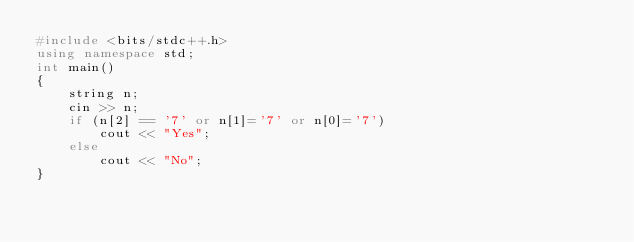Convert code to text. <code><loc_0><loc_0><loc_500><loc_500><_C++_>#include <bits/stdc++.h>
using namespace std;
int main()
{
    string n;
    cin >> n;
    if (n[2] == '7' or n[1]='7' or n[0]='7')
        cout << "Yes";
    else
        cout << "No";
}</code> 